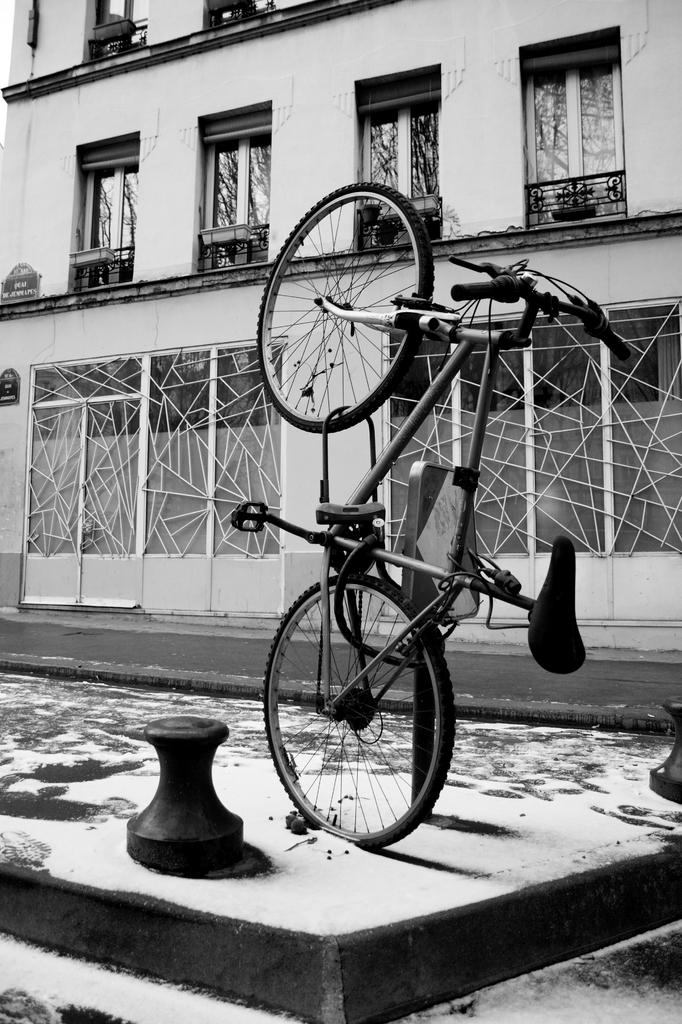What is the main subject in the center of the image? There is a bicycle in the center of the image. What can be seen in the background of the image? There is a building in the background of the image. What is located at the bottom of the image? There is a road at the bottom of the image. What type of pen is being used to draw on the bicycle in the image? There is no pen or drawing activity present in the image; it features a bicycle, a building in the background, and a road at the bottom. 